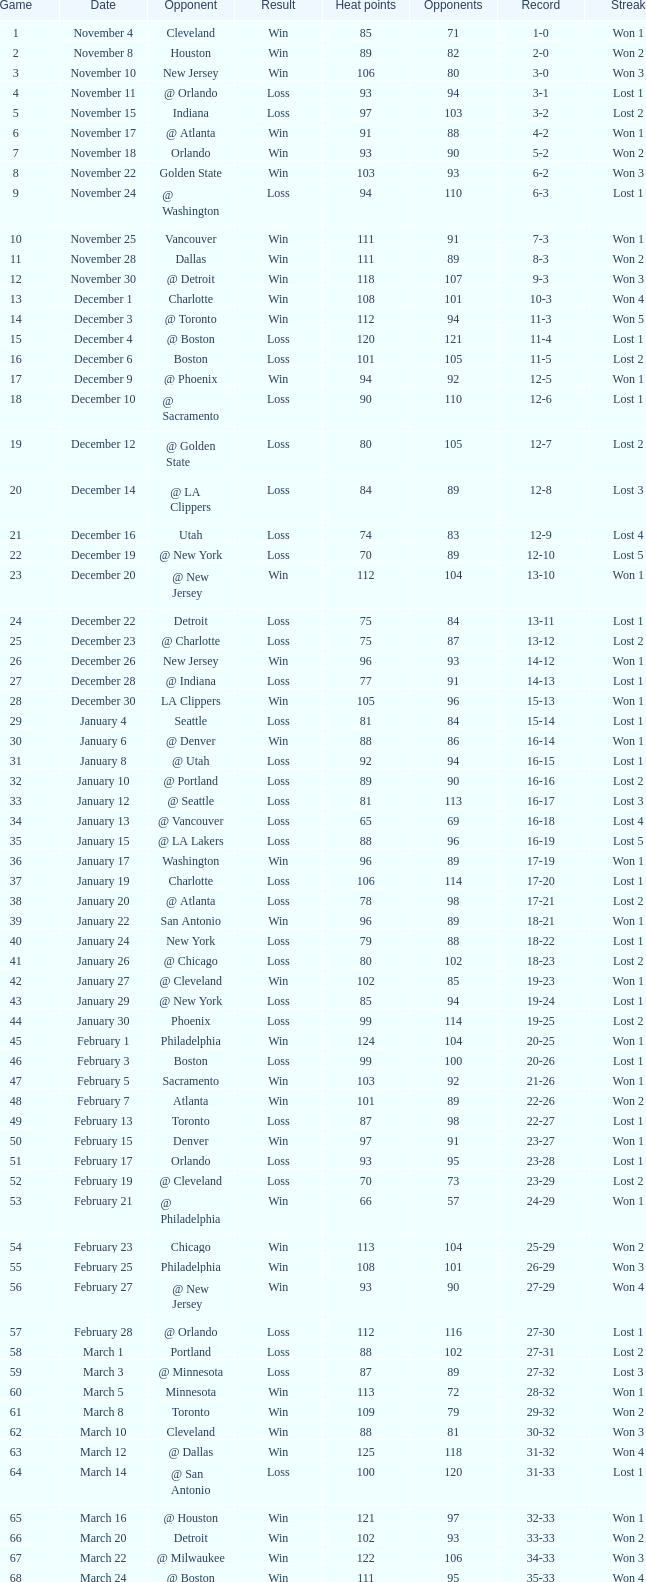I'm looking to parse the entire table for insights. Could you assist me with that? {'header': ['Game', 'Date', 'Opponent', 'Result', 'Heat points', 'Opponents', 'Record', 'Streak'], 'rows': [['1', 'November 4', 'Cleveland', 'Win', '85', '71', '1-0', 'Won 1'], ['2', 'November 8', 'Houston', 'Win', '89', '82', '2-0', 'Won 2'], ['3', 'November 10', 'New Jersey', 'Win', '106', '80', '3-0', 'Won 3'], ['4', 'November 11', '@ Orlando', 'Loss', '93', '94', '3-1', 'Lost 1'], ['5', 'November 15', 'Indiana', 'Loss', '97', '103', '3-2', 'Lost 2'], ['6', 'November 17', '@ Atlanta', 'Win', '91', '88', '4-2', 'Won 1'], ['7', 'November 18', 'Orlando', 'Win', '93', '90', '5-2', 'Won 2'], ['8', 'November 22', 'Golden State', 'Win', '103', '93', '6-2', 'Won 3'], ['9', 'November 24', '@ Washington', 'Loss', '94', '110', '6-3', 'Lost 1'], ['10', 'November 25', 'Vancouver', 'Win', '111', '91', '7-3', 'Won 1'], ['11', 'November 28', 'Dallas', 'Win', '111', '89', '8-3', 'Won 2'], ['12', 'November 30', '@ Detroit', 'Win', '118', '107', '9-3', 'Won 3'], ['13', 'December 1', 'Charlotte', 'Win', '108', '101', '10-3', 'Won 4'], ['14', 'December 3', '@ Toronto', 'Win', '112', '94', '11-3', 'Won 5'], ['15', 'December 4', '@ Boston', 'Loss', '120', '121', '11-4', 'Lost 1'], ['16', 'December 6', 'Boston', 'Loss', '101', '105', '11-5', 'Lost 2'], ['17', 'December 9', '@ Phoenix', 'Win', '94', '92', '12-5', 'Won 1'], ['18', 'December 10', '@ Sacramento', 'Loss', '90', '110', '12-6', 'Lost 1'], ['19', 'December 12', '@ Golden State', 'Loss', '80', '105', '12-7', 'Lost 2'], ['20', 'December 14', '@ LA Clippers', 'Loss', '84', '89', '12-8', 'Lost 3'], ['21', 'December 16', 'Utah', 'Loss', '74', '83', '12-9', 'Lost 4'], ['22', 'December 19', '@ New York', 'Loss', '70', '89', '12-10', 'Lost 5'], ['23', 'December 20', '@ New Jersey', 'Win', '112', '104', '13-10', 'Won 1'], ['24', 'December 22', 'Detroit', 'Loss', '75', '84', '13-11', 'Lost 1'], ['25', 'December 23', '@ Charlotte', 'Loss', '75', '87', '13-12', 'Lost 2'], ['26', 'December 26', 'New Jersey', 'Win', '96', '93', '14-12', 'Won 1'], ['27', 'December 28', '@ Indiana', 'Loss', '77', '91', '14-13', 'Lost 1'], ['28', 'December 30', 'LA Clippers', 'Win', '105', '96', '15-13', 'Won 1'], ['29', 'January 4', 'Seattle', 'Loss', '81', '84', '15-14', 'Lost 1'], ['30', 'January 6', '@ Denver', 'Win', '88', '86', '16-14', 'Won 1'], ['31', 'January 8', '@ Utah', 'Loss', '92', '94', '16-15', 'Lost 1'], ['32', 'January 10', '@ Portland', 'Loss', '89', '90', '16-16', 'Lost 2'], ['33', 'January 12', '@ Seattle', 'Loss', '81', '113', '16-17', 'Lost 3'], ['34', 'January 13', '@ Vancouver', 'Loss', '65', '69', '16-18', 'Lost 4'], ['35', 'January 15', '@ LA Lakers', 'Loss', '88', '96', '16-19', 'Lost 5'], ['36', 'January 17', 'Washington', 'Win', '96', '89', '17-19', 'Won 1'], ['37', 'January 19', 'Charlotte', 'Loss', '106', '114', '17-20', 'Lost 1'], ['38', 'January 20', '@ Atlanta', 'Loss', '78', '98', '17-21', 'Lost 2'], ['39', 'January 22', 'San Antonio', 'Win', '96', '89', '18-21', 'Won 1'], ['40', 'January 24', 'New York', 'Loss', '79', '88', '18-22', 'Lost 1'], ['41', 'January 26', '@ Chicago', 'Loss', '80', '102', '18-23', 'Lost 2'], ['42', 'January 27', '@ Cleveland', 'Win', '102', '85', '19-23', 'Won 1'], ['43', 'January 29', '@ New York', 'Loss', '85', '94', '19-24', 'Lost 1'], ['44', 'January 30', 'Phoenix', 'Loss', '99', '114', '19-25', 'Lost 2'], ['45', 'February 1', 'Philadelphia', 'Win', '124', '104', '20-25', 'Won 1'], ['46', 'February 3', 'Boston', 'Loss', '99', '100', '20-26', 'Lost 1'], ['47', 'February 5', 'Sacramento', 'Win', '103', '92', '21-26', 'Won 1'], ['48', 'February 7', 'Atlanta', 'Win', '101', '89', '22-26', 'Won 2'], ['49', 'February 13', 'Toronto', 'Loss', '87', '98', '22-27', 'Lost 1'], ['50', 'February 15', 'Denver', 'Win', '97', '91', '23-27', 'Won 1'], ['51', 'February 17', 'Orlando', 'Loss', '93', '95', '23-28', 'Lost 1'], ['52', 'February 19', '@ Cleveland', 'Loss', '70', '73', '23-29', 'Lost 2'], ['53', 'February 21', '@ Philadelphia', 'Win', '66', '57', '24-29', 'Won 1'], ['54', 'February 23', 'Chicago', 'Win', '113', '104', '25-29', 'Won 2'], ['55', 'February 25', 'Philadelphia', 'Win', '108', '101', '26-29', 'Won 3'], ['56', 'February 27', '@ New Jersey', 'Win', '93', '90', '27-29', 'Won 4'], ['57', 'February 28', '@ Orlando', 'Loss', '112', '116', '27-30', 'Lost 1'], ['58', 'March 1', 'Portland', 'Loss', '88', '102', '27-31', 'Lost 2'], ['59', 'March 3', '@ Minnesota', 'Loss', '87', '89', '27-32', 'Lost 3'], ['60', 'March 5', 'Minnesota', 'Win', '113', '72', '28-32', 'Won 1'], ['61', 'March 8', 'Toronto', 'Win', '109', '79', '29-32', 'Won 2'], ['62', 'March 10', 'Cleveland', 'Win', '88', '81', '30-32', 'Won 3'], ['63', 'March 12', '@ Dallas', 'Win', '125', '118', '31-32', 'Won 4'], ['64', 'March 14', '@ San Antonio', 'Loss', '100', '120', '31-33', 'Lost 1'], ['65', 'March 16', '@ Houston', 'Win', '121', '97', '32-33', 'Won 1'], ['66', 'March 20', 'Detroit', 'Win', '102', '93', '33-33', 'Won 2'], ['67', 'March 22', '@ Milwaukee', 'Win', '122', '106', '34-33', 'Won 3'], ['68', 'March 24', '@ Boston', 'Win', '111', '95', '35-33', 'Won 4'], ['69', 'March 27', 'LA Lakers', 'Loss', '95', '106', '35-34', 'Lost 1'], ['70', 'March 29', 'Washington', 'Win', '112', '93', '36-34', 'Won 1'], ['71', 'March 30', '@ Detroit', 'Win', '95', '85', '37-34', 'Won 2'], ['72', 'April 2', 'Chicago', 'Loss', '92', '110', '37-35', 'Lost 1'], ['73', 'April 4', '@ Chicago', 'Loss', '92', '100', '37-36', 'Lost 2'], ['74', 'April 6', '@ Indiana', 'Loss', '95', '99', '37-37', 'Lost 3'], ['75', 'April 8', '@ Washington', 'Loss', '99', '111', '37-38', 'Lost 4'], ['76', 'April 10', '@ Charlotte', 'Win', '116', '95', '38-38', 'Won 1'], ['77', 'April 11', 'Milwaukee', 'Win', '115', '105', '39-38', 'Won 2'], ['78', 'April 13', 'New York', 'Win', '103', '95', '40-38', 'Won 3'], ['79', 'April 15', 'New Jersey', 'Win', '110', '90', '41-38', 'Won 4'], ['80', 'April 17', '@ Philadelphia', 'Loss', '86', '90', '41-39', 'Lost 1'], ['81', 'April 19', '@ Milwaukee', 'Win', '106', '100', '42-39', 'Won 1'], ['82', 'April 21', 'Atlanta', 'Loss', '92', '104', '42-40', 'Lost 1'], ['1', 'April 26 (First Round)', '@ Chicago', 'Loss', '85', '102', '0-1', 'Lost 1'], ['2', 'April 28 (First Round)', '@ Chicago', 'Loss', '75', '106', '0-2', 'Lost 2'], ['3', 'May 1 (First Round)', 'Chicago', 'Loss', '91', '112', '0-3', 'Lost 3']]} What is the average Heat Points, when Result is "Loss", when Game is greater than 72, and when Date is "April 21"? 92.0. 